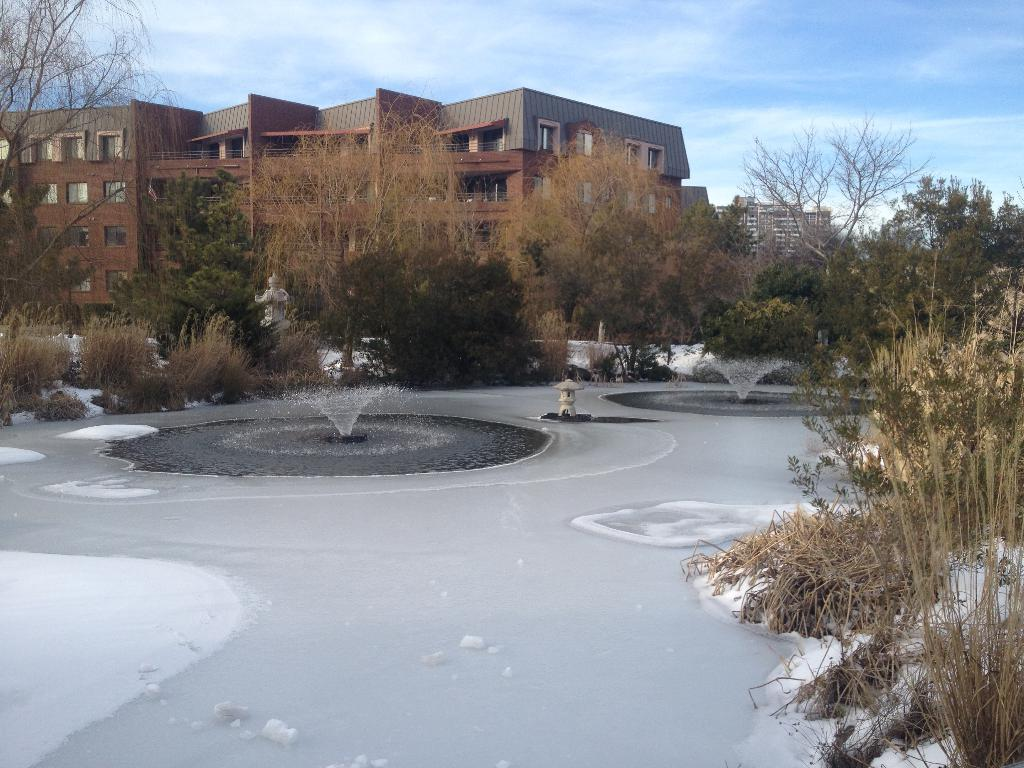What is present in the image that is related to water? There is water in the image. What is the main subject of the image? There is a statue in the image. What type of vegetation can be seen in the image? There are trees in the image. What type of structures are visible in the image? There are buildings with windows in the image. What else can be seen in the image besides the statue, trees, and buildings? There are some objects in the image. What is visible in the background of the image? The sky is visible in the background of the image. Can you tell me how many toes are visible on the statue in the image? There is no mention of toes or any body parts on the statue in the provided facts, so it is not possible to answer that question. 